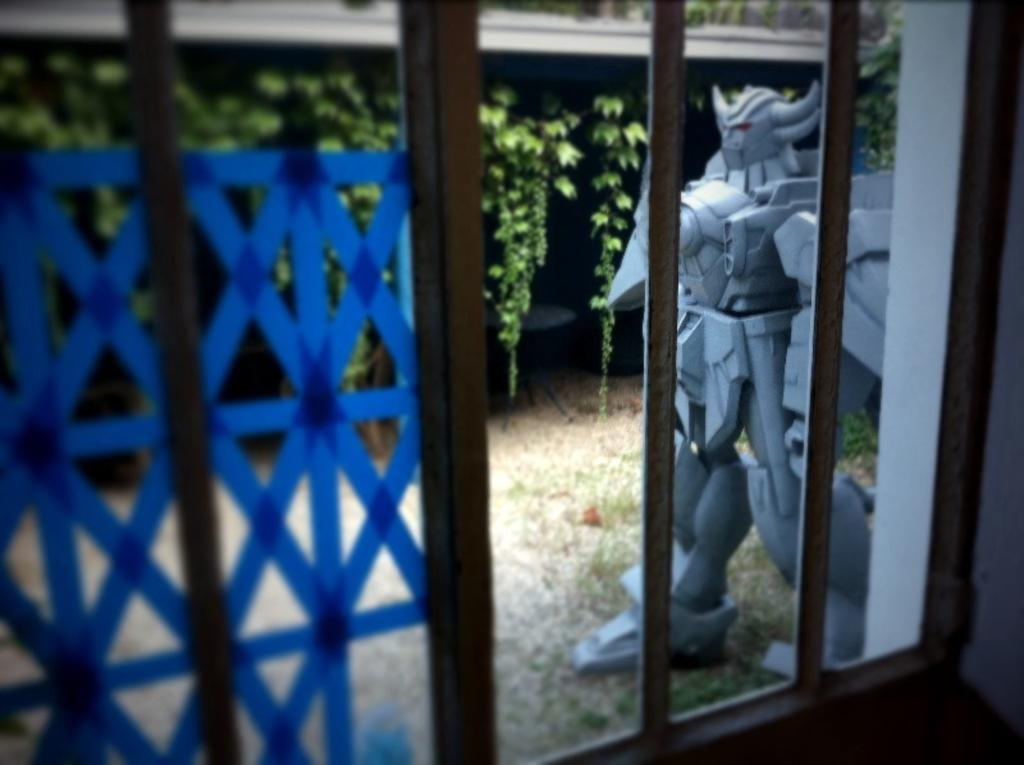What type of material is used for the windows in the wall? The windows in the wall are made of glass. What can be seen on the ground outside the window? Toys are present on the ground outside the window. What is located behind the toys on the ground? There are plants behind the toys. What type of thought is expressed by the rabbit in the image? There is no rabbit present in the image, so it is not possible to determine any thoughts expressed by a rabbit. 